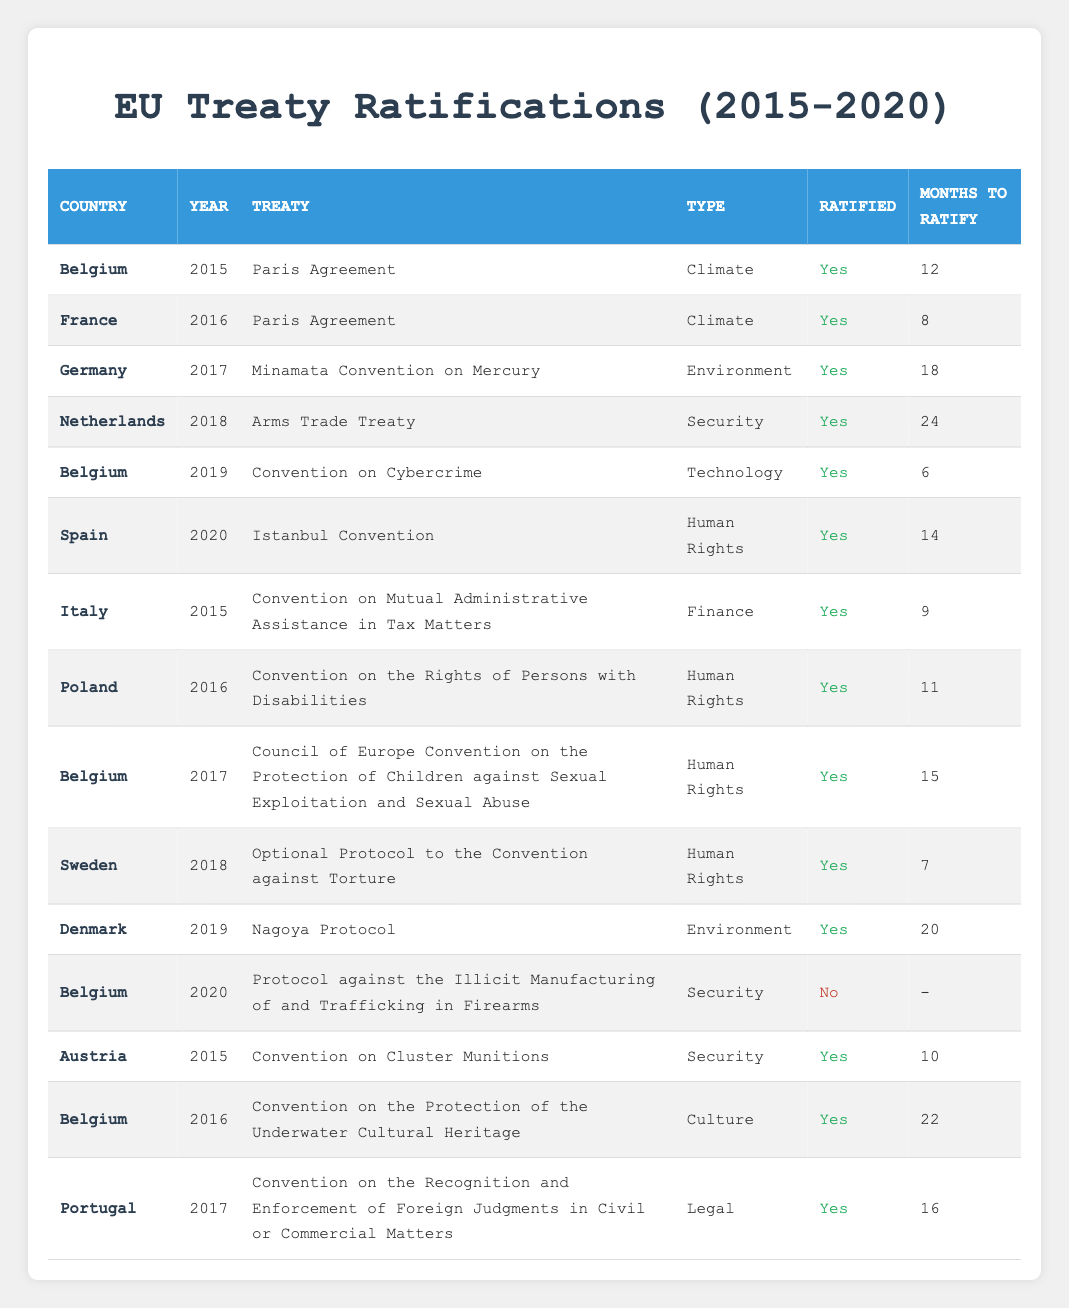What treaties did Belgium ratify in 2015? Belgium ratified the "Paris Agreement" in 2015. This can be found by filtering the table for Belgium in the year 2015 and locating the corresponding treaty.
Answer: Paris Agreement Which country ratified the "Istanbul Convention"? The "Istanbul Convention" was ratified by Spain in the year 2020. This is determined by looking for the specific treaty in the table and checking the corresponding country for that year.
Answer: Spain How many months did Belgium take to ratify the "Council of Europe Convention on the Protection of Children against Sexual Exploitation and Sexual Abuse"? Belgium ratified this treaty in 2017, taking 15 months to do so. This can be found by locating Belgium under the year 2017 and checking the months to ratify for the specific treaty.
Answer: 15 Did Denmark ratify the "Nagoya Protocol"? Yes, Denmark ratified the "Nagoya Protocol" in 2019. This can be confirmed by looking at the table for Denmark in the year 2019 and checking the ratification status for that treaty.
Answer: Yes What is the average number of months for all treaties ratified by Belgium across the years listed? To calculate the average, we take the total number of months for treaties ratified by Belgium, which are 12 (Paris Agreement, 2015), 6 (Convention on Cybercrime, 2019), 15 (Council of Europe Convention, 2017), and 22 (Convention on the Protection of the Underwater Cultural Heritage, 2016). The sum is 12 + 6 + 15 + 22 = 55. There are 4 ratifications, so the average is 55/4 = 13.75.
Answer: 13.75 How many treaties were ratified in 2016? In 2016, there were 4 treaties ratified according to the table. This is determined by counting the number of rows in the table for the year 2016 where the ratification status is 'Yes'.
Answer: 4 